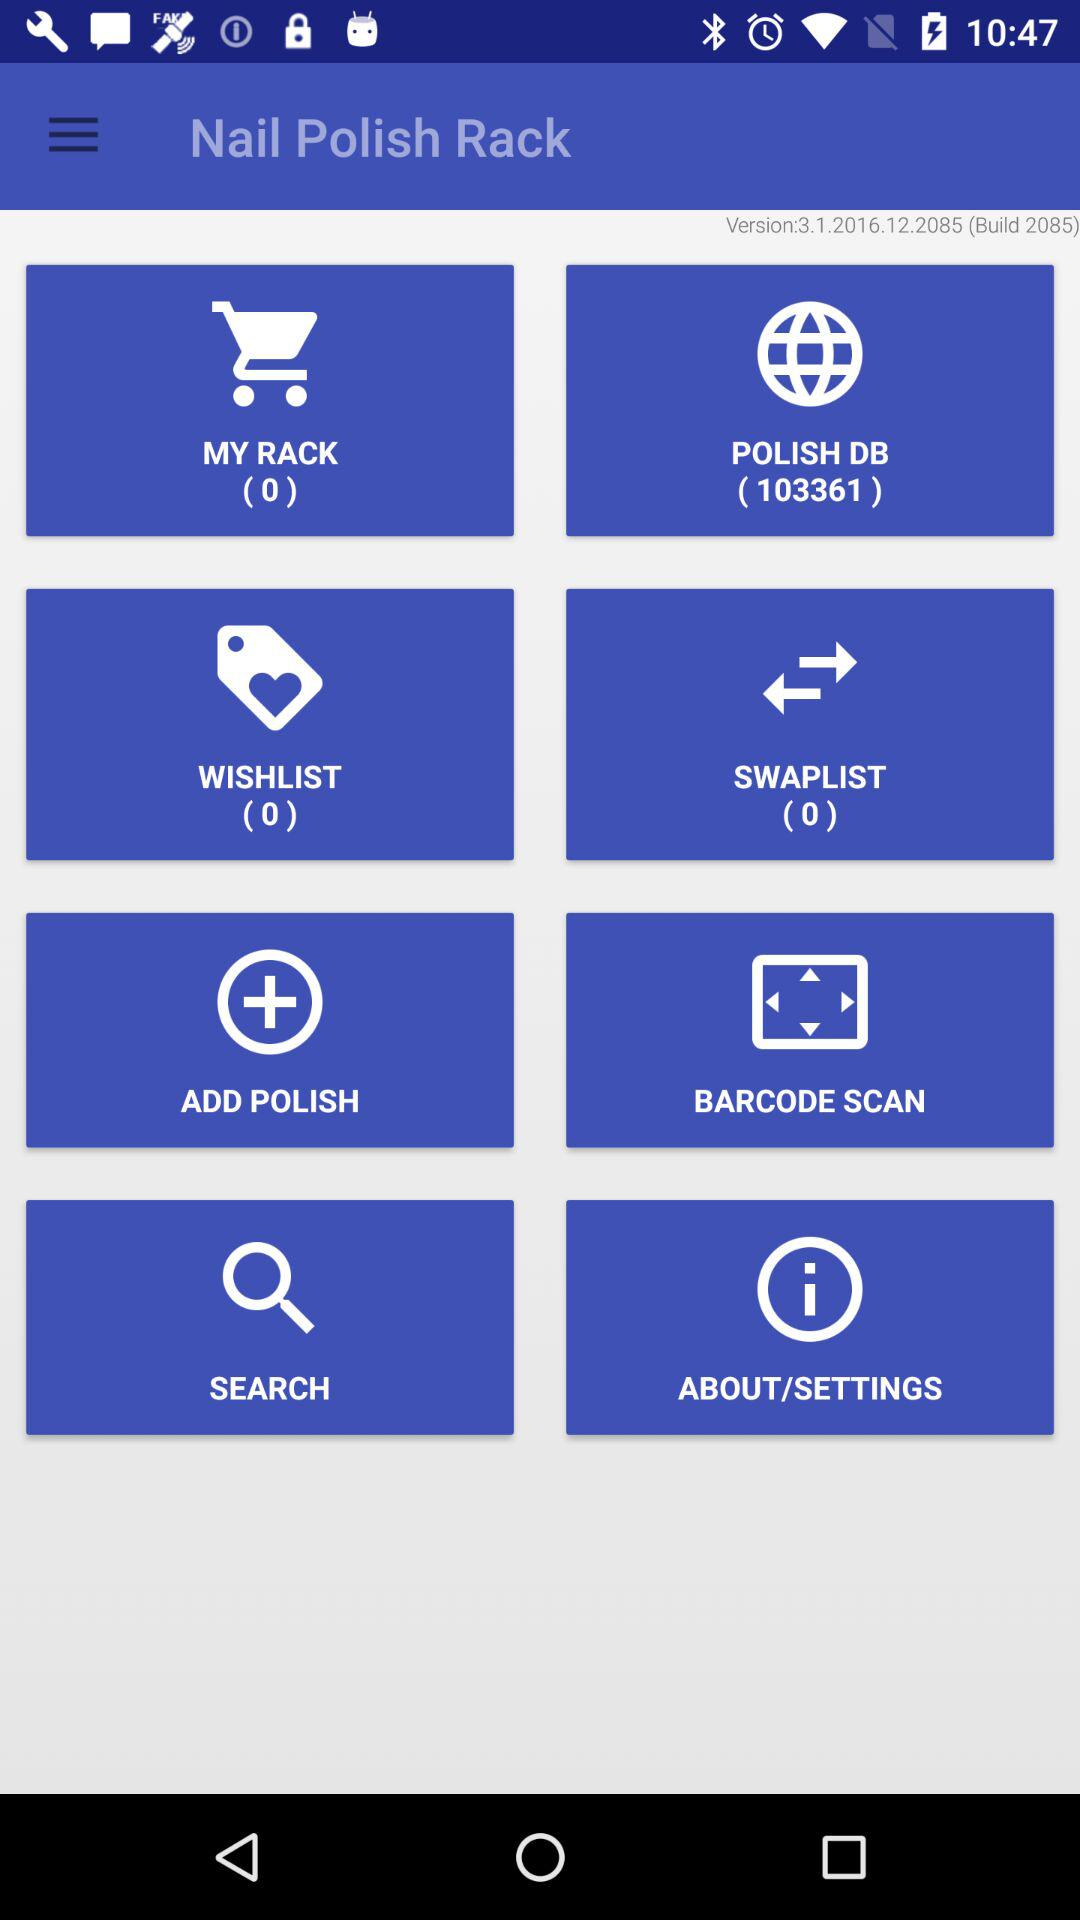What is the name of the application? The name of the application is "Nail Polish Rack". 